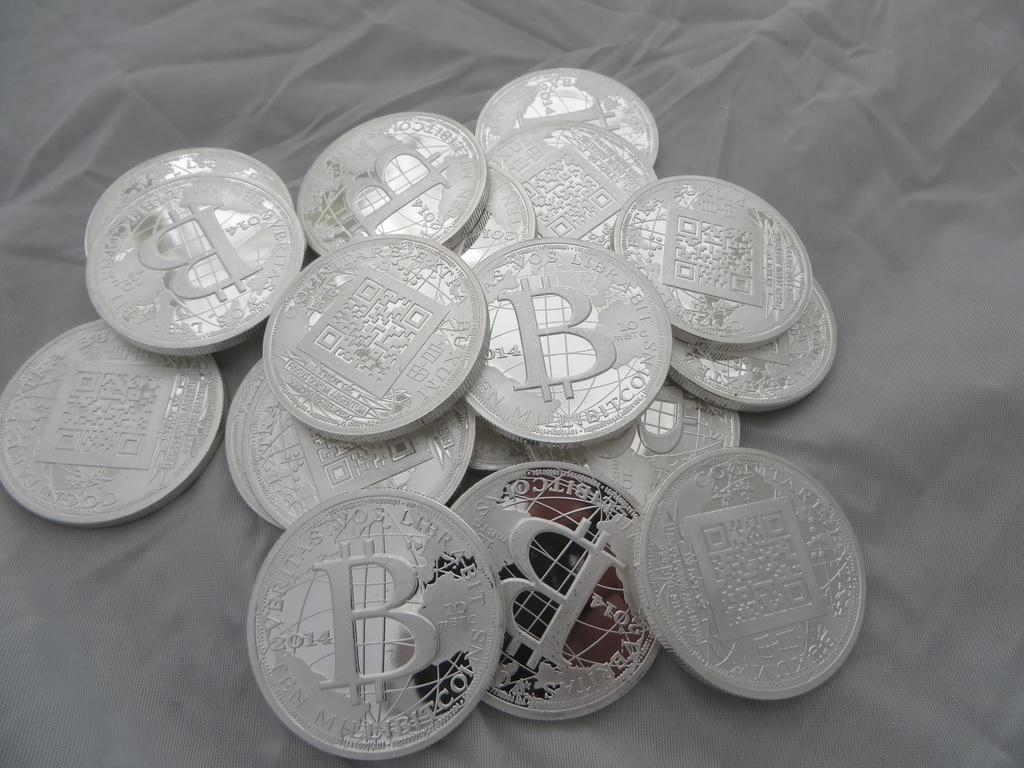<image>
Describe the image concisely. Shiny silver coins with the letter B on them sit in a small pile. 